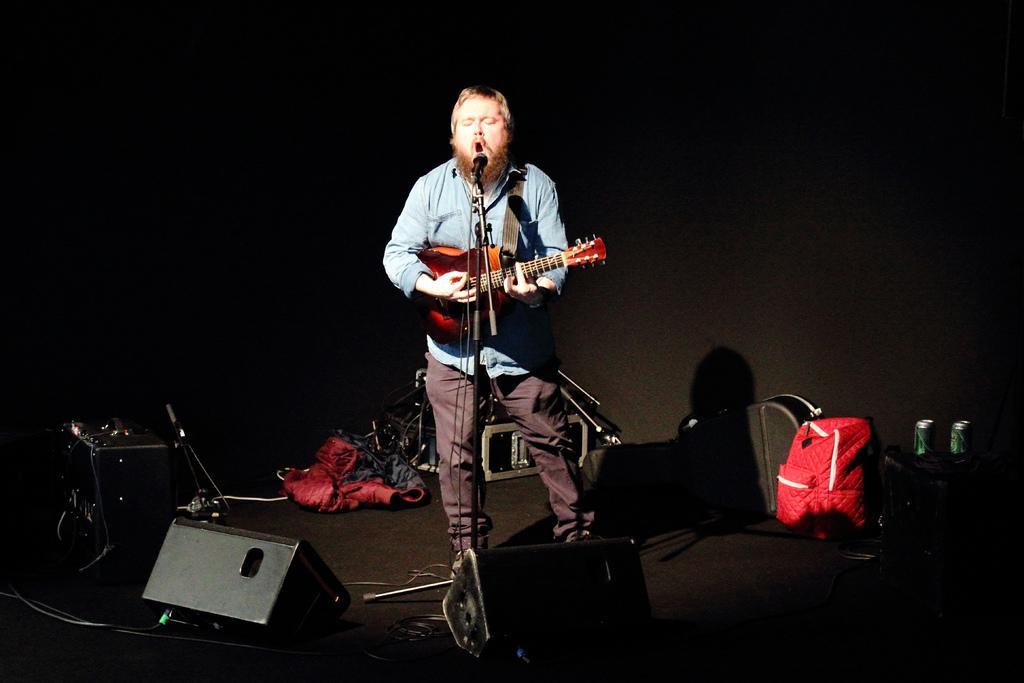Could you give a brief overview of what you see in this image? Background is dark. On the platform we can see device, backpack, tins, guitar bag. We can see a man standing in front of a mike singing and playing guitar. 